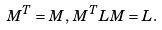Convert formula to latex. <formula><loc_0><loc_0><loc_500><loc_500>M ^ { T } = M , \, M ^ { T } L M = L .</formula> 